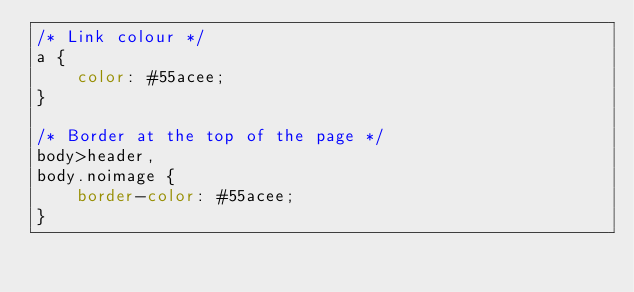Convert code to text. <code><loc_0><loc_0><loc_500><loc_500><_CSS_>/* Link colour */
a {
    color: #55acee;
}

/* Border at the top of the page */
body>header,
body.noimage {
    border-color: #55acee;
}
</code> 